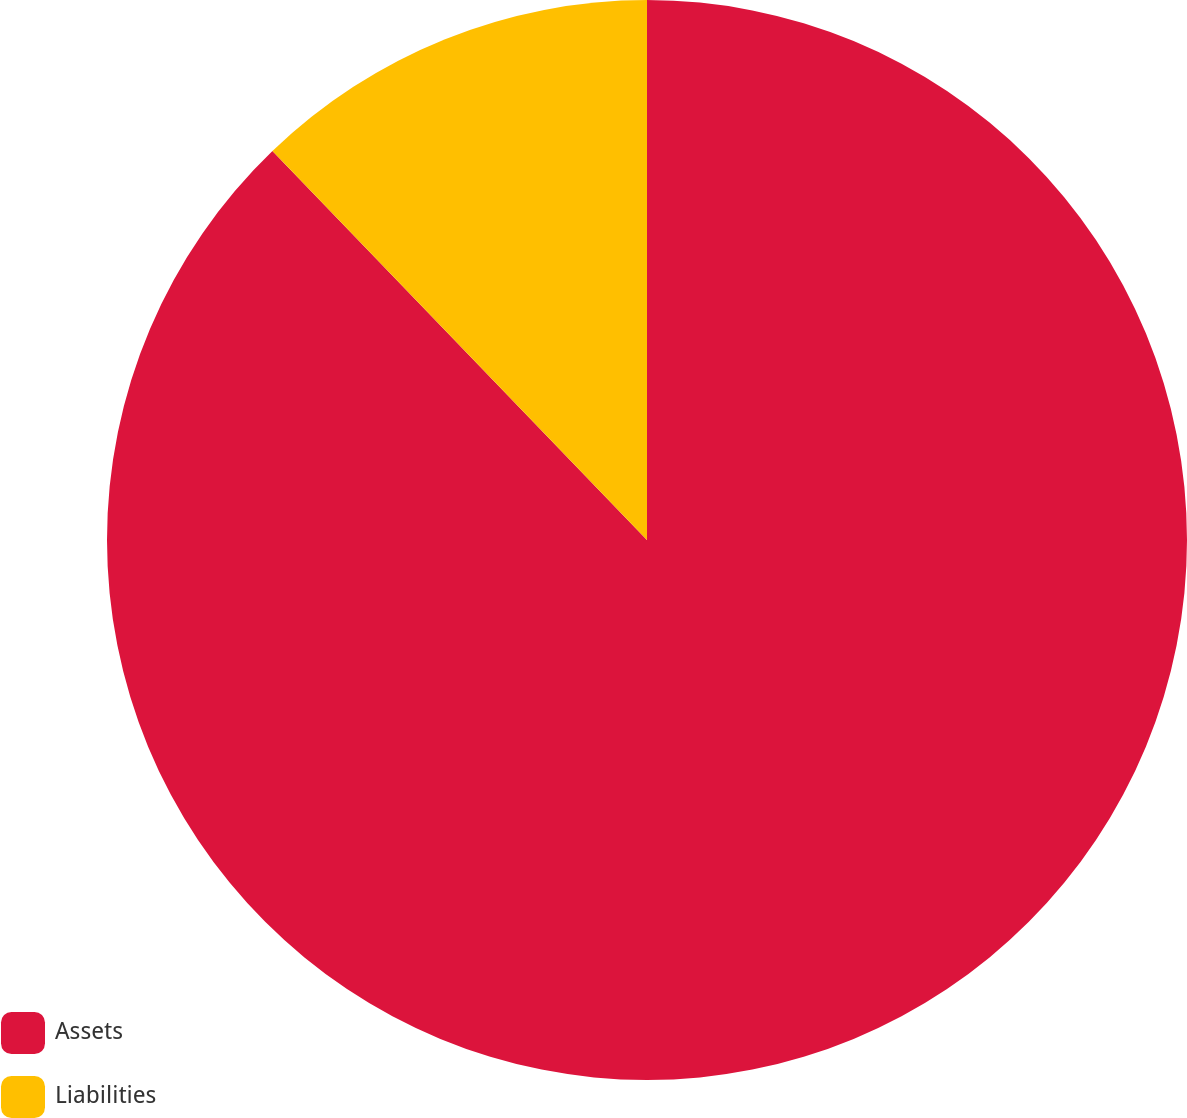Convert chart. <chart><loc_0><loc_0><loc_500><loc_500><pie_chart><fcel>Assets<fcel>Liabilities<nl><fcel>87.8%<fcel>12.2%<nl></chart> 